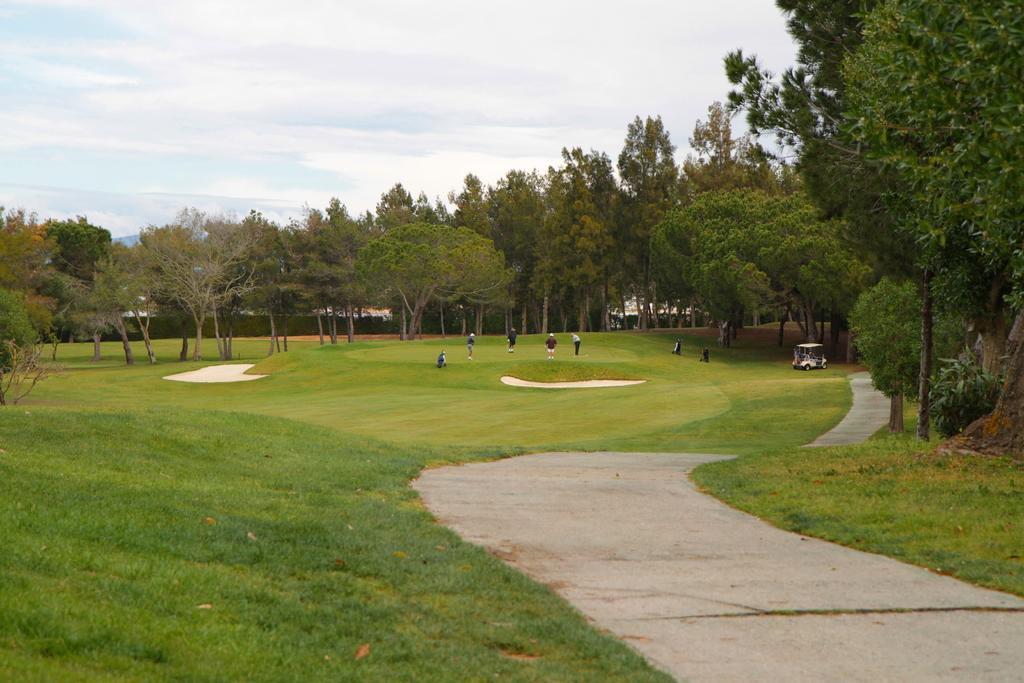Could you give a brief overview of what you see in this image? This is a ground. On the right side, I can see a road. On both sides of the road I can see the grass. In the background, I can see few people are playing. On the right side there is a vehicle. In the background there are many trees. At the top I can see the sky. 